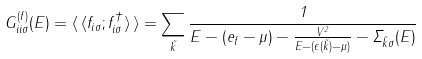<formula> <loc_0><loc_0><loc_500><loc_500>G _ { i i \sigma } ^ { ( f ) } ( E ) = \langle \, \langle f _ { i \sigma } ; f _ { i \sigma } ^ { \dagger } \rangle \, \rangle = \sum _ { \vec { k } } \frac { 1 } { E - ( e _ { f } - \mu ) - \frac { V ^ { 2 } } { E - ( \epsilon ( \vec { k } ) - \mu ) } - \Sigma _ { \vec { k } \sigma } ( E ) }</formula> 